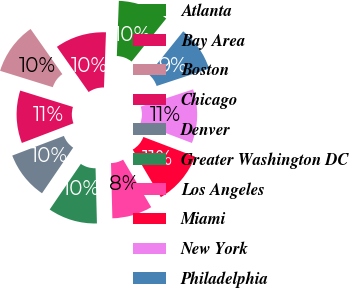Convert chart to OTSL. <chart><loc_0><loc_0><loc_500><loc_500><pie_chart><fcel>Atlanta<fcel>Bay Area<fcel>Boston<fcel>Chicago<fcel>Denver<fcel>Greater Washington DC<fcel>Los Angeles<fcel>Miami<fcel>New York<fcel>Philadelphia<nl><fcel>10.2%<fcel>10.33%<fcel>10.46%<fcel>10.59%<fcel>9.67%<fcel>9.93%<fcel>8.1%<fcel>10.72%<fcel>10.86%<fcel>9.14%<nl></chart> 